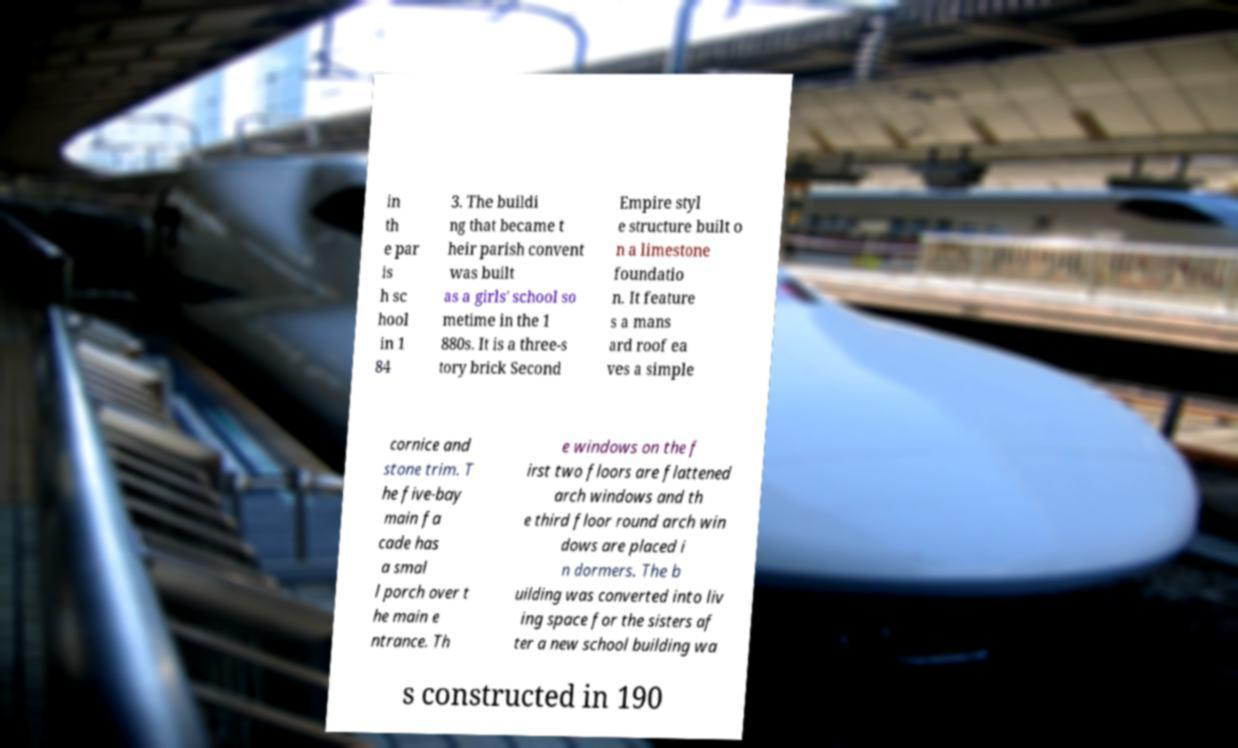I need the written content from this picture converted into text. Can you do that? in th e par is h sc hool in 1 84 3. The buildi ng that became t heir parish convent was built as a girls' school so metime in the 1 880s. It is a three-s tory brick Second Empire styl e structure built o n a limestone foundatio n. It feature s a mans ard roof ea ves a simple cornice and stone trim. T he five-bay main fa cade has a smal l porch over t he main e ntrance. Th e windows on the f irst two floors are flattened arch windows and th e third floor round arch win dows are placed i n dormers. The b uilding was converted into liv ing space for the sisters af ter a new school building wa s constructed in 190 